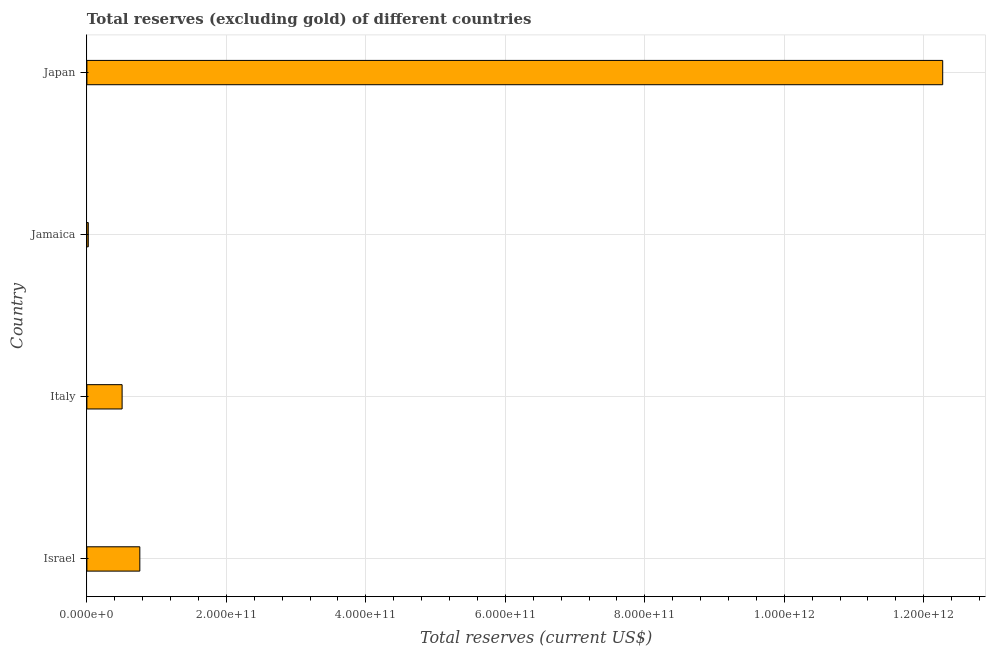What is the title of the graph?
Your response must be concise. Total reserves (excluding gold) of different countries. What is the label or title of the X-axis?
Ensure brevity in your answer.  Total reserves (current US$). What is the label or title of the Y-axis?
Offer a very short reply. Country. What is the total reserves (excluding gold) in Japan?
Provide a succinct answer. 1.23e+12. Across all countries, what is the maximum total reserves (excluding gold)?
Ensure brevity in your answer.  1.23e+12. Across all countries, what is the minimum total reserves (excluding gold)?
Offer a terse response. 2.00e+09. In which country was the total reserves (excluding gold) maximum?
Make the answer very short. Japan. In which country was the total reserves (excluding gold) minimum?
Ensure brevity in your answer.  Jamaica. What is the sum of the total reserves (excluding gold)?
Your response must be concise. 1.36e+12. What is the difference between the total reserves (excluding gold) in Italy and Japan?
Keep it short and to the point. -1.18e+12. What is the average total reserves (excluding gold) per country?
Your response must be concise. 3.39e+11. What is the median total reserves (excluding gold)?
Make the answer very short. 6.32e+1. What is the ratio of the total reserves (excluding gold) in Italy to that in Japan?
Provide a short and direct response. 0.04. What is the difference between the highest and the second highest total reserves (excluding gold)?
Provide a short and direct response. 1.15e+12. What is the difference between the highest and the lowest total reserves (excluding gold)?
Your answer should be very brief. 1.23e+12. How many countries are there in the graph?
Offer a very short reply. 4. What is the difference between two consecutive major ticks on the X-axis?
Your response must be concise. 2.00e+11. Are the values on the major ticks of X-axis written in scientific E-notation?
Your answer should be compact. Yes. What is the Total reserves (current US$) of Israel?
Your answer should be very brief. 7.59e+1. What is the Total reserves (current US$) in Italy?
Keep it short and to the point. 5.05e+1. What is the Total reserves (current US$) in Jamaica?
Give a very brief answer. 2.00e+09. What is the Total reserves (current US$) of Japan?
Offer a terse response. 1.23e+12. What is the difference between the Total reserves (current US$) in Israel and Italy?
Offer a terse response. 2.54e+1. What is the difference between the Total reserves (current US$) in Israel and Jamaica?
Provide a short and direct response. 7.39e+1. What is the difference between the Total reserves (current US$) in Israel and Japan?
Offer a terse response. -1.15e+12. What is the difference between the Total reserves (current US$) in Italy and Jamaica?
Your answer should be very brief. 4.85e+1. What is the difference between the Total reserves (current US$) in Italy and Japan?
Make the answer very short. -1.18e+12. What is the difference between the Total reserves (current US$) in Jamaica and Japan?
Provide a short and direct response. -1.23e+12. What is the ratio of the Total reserves (current US$) in Israel to that in Italy?
Provide a succinct answer. 1.5. What is the ratio of the Total reserves (current US$) in Israel to that in Jamaica?
Provide a short and direct response. 38.02. What is the ratio of the Total reserves (current US$) in Israel to that in Japan?
Provide a succinct answer. 0.06. What is the ratio of the Total reserves (current US$) in Italy to that in Jamaica?
Give a very brief answer. 25.29. What is the ratio of the Total reserves (current US$) in Italy to that in Japan?
Provide a short and direct response. 0.04. What is the ratio of the Total reserves (current US$) in Jamaica to that in Japan?
Keep it short and to the point. 0. 